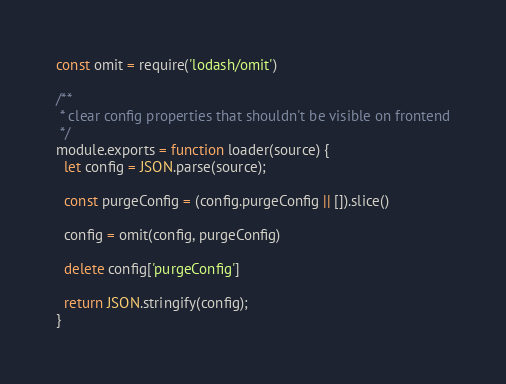<code> <loc_0><loc_0><loc_500><loc_500><_JavaScript_>const omit = require('lodash/omit')

/**
 * clear config properties that shouldn't be visible on frontend
 */
module.exports = function loader(source) {
  let config = JSON.parse(source);

  const purgeConfig = (config.purgeConfig || []).slice()

  config = omit(config, purgeConfig)

  delete config['purgeConfig']

  return JSON.stringify(config);
}
</code> 